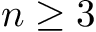Convert formula to latex. <formula><loc_0><loc_0><loc_500><loc_500>n \geq 3</formula> 